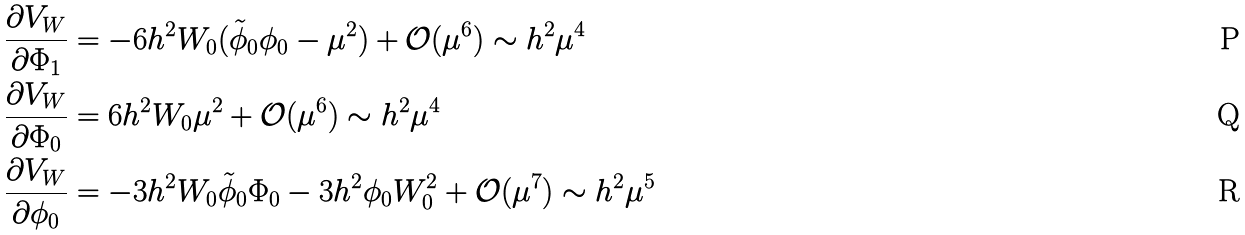<formula> <loc_0><loc_0><loc_500><loc_500>\frac { \partial V _ { W } } { \partial \Phi _ { 1 } } & = - 6 h ^ { 2 } W _ { 0 } ( \tilde { \phi } _ { 0 } \phi _ { 0 } - \mu ^ { 2 } ) + \mathcal { O } ( \mu ^ { 6 } ) \sim h ^ { 2 } \mu ^ { 4 } \\ \frac { \partial V _ { W } } { \partial \Phi _ { 0 } } & = 6 h ^ { 2 } W _ { 0 } \mu ^ { 2 } + \mathcal { O } ( \mu ^ { 6 } ) \sim h ^ { 2 } \mu ^ { 4 } \\ \frac { \partial V _ { W } } { \partial \phi _ { 0 } } & = - 3 h ^ { 2 } W _ { 0 } \tilde { \phi } _ { 0 } \Phi _ { 0 } - 3 h ^ { 2 } \phi _ { 0 } W _ { 0 } ^ { 2 } + \mathcal { O } ( \mu ^ { 7 } ) \sim h ^ { 2 } \mu ^ { 5 }</formula> 